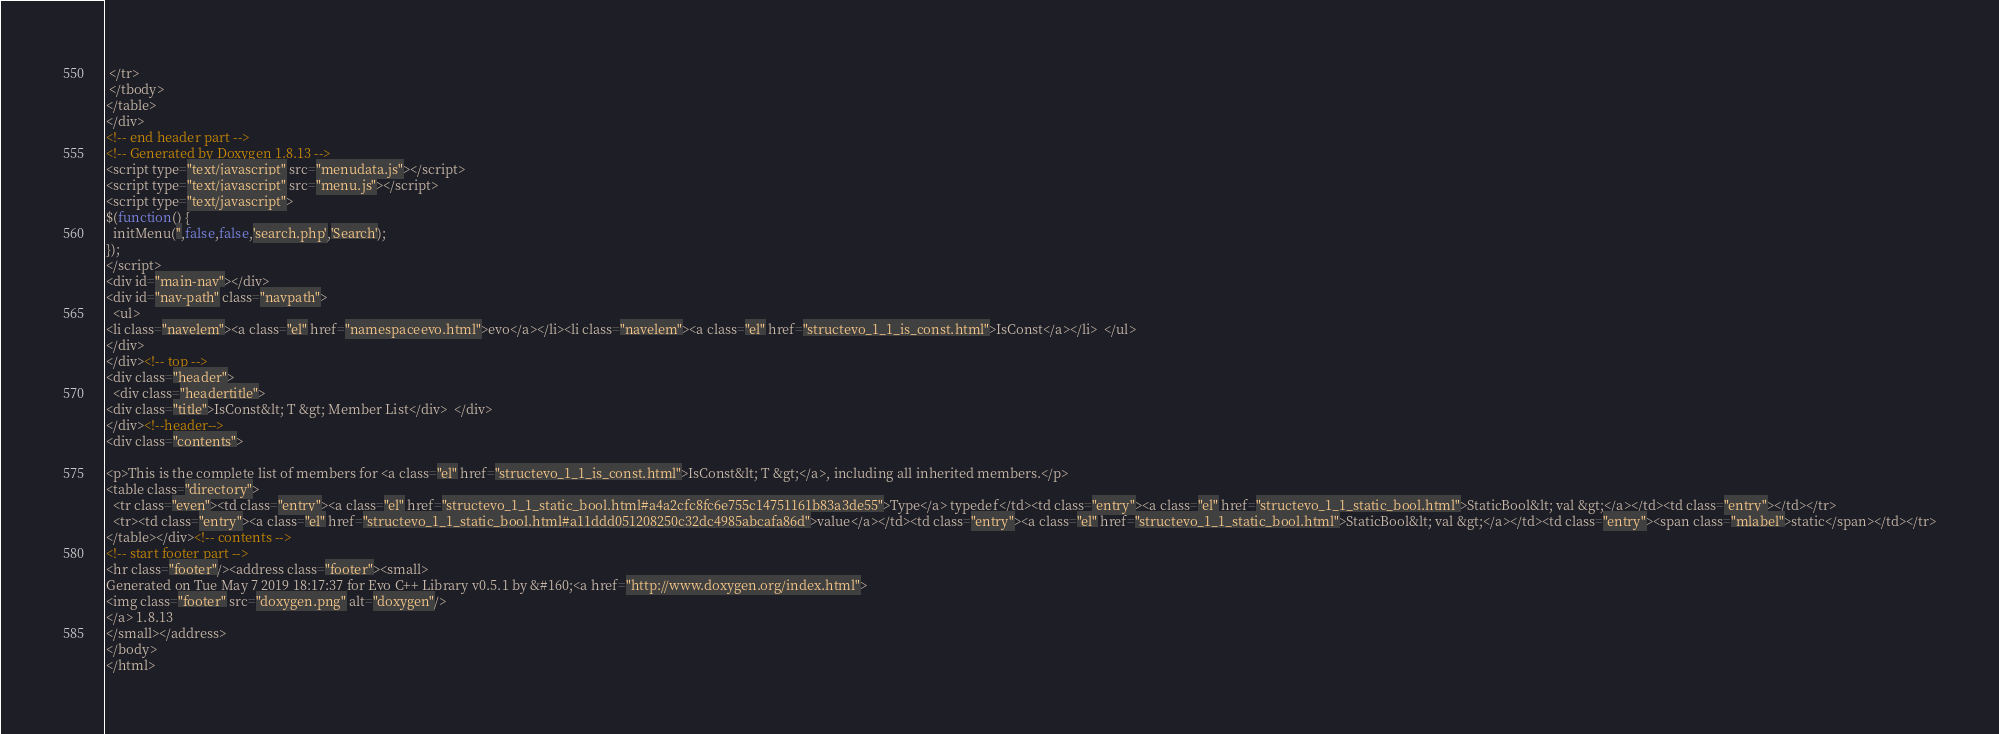<code> <loc_0><loc_0><loc_500><loc_500><_HTML_> </tr>
 </tbody>
</table>
</div>
<!-- end header part -->
<!-- Generated by Doxygen 1.8.13 -->
<script type="text/javascript" src="menudata.js"></script>
<script type="text/javascript" src="menu.js"></script>
<script type="text/javascript">
$(function() {
  initMenu('',false,false,'search.php','Search');
});
</script>
<div id="main-nav"></div>
<div id="nav-path" class="navpath">
  <ul>
<li class="navelem"><a class="el" href="namespaceevo.html">evo</a></li><li class="navelem"><a class="el" href="structevo_1_1_is_const.html">IsConst</a></li>  </ul>
</div>
</div><!-- top -->
<div class="header">
  <div class="headertitle">
<div class="title">IsConst&lt; T &gt; Member List</div>  </div>
</div><!--header-->
<div class="contents">

<p>This is the complete list of members for <a class="el" href="structevo_1_1_is_const.html">IsConst&lt; T &gt;</a>, including all inherited members.</p>
<table class="directory">
  <tr class="even"><td class="entry"><a class="el" href="structevo_1_1_static_bool.html#a4a2cfc8fc6e755c14751161b83a3de55">Type</a> typedef</td><td class="entry"><a class="el" href="structevo_1_1_static_bool.html">StaticBool&lt; val &gt;</a></td><td class="entry"></td></tr>
  <tr><td class="entry"><a class="el" href="structevo_1_1_static_bool.html#a11ddd051208250c32dc4985abcafa86d">value</a></td><td class="entry"><a class="el" href="structevo_1_1_static_bool.html">StaticBool&lt; val &gt;</a></td><td class="entry"><span class="mlabel">static</span></td></tr>
</table></div><!-- contents -->
<!-- start footer part -->
<hr class="footer"/><address class="footer"><small>
Generated on Tue May 7 2019 18:17:37 for Evo C++ Library v0.5.1 by &#160;<a href="http://www.doxygen.org/index.html">
<img class="footer" src="doxygen.png" alt="doxygen"/>
</a> 1.8.13
</small></address>
</body>
</html>
</code> 